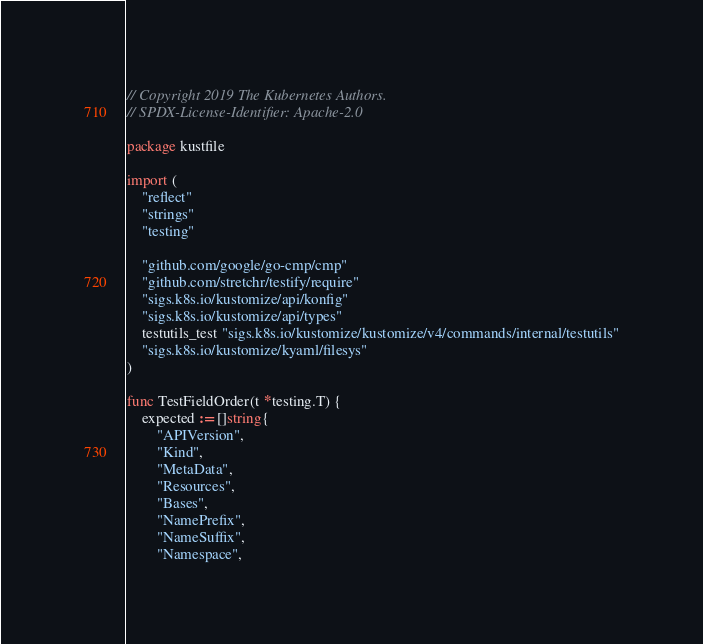Convert code to text. <code><loc_0><loc_0><loc_500><loc_500><_Go_>// Copyright 2019 The Kubernetes Authors.
// SPDX-License-Identifier: Apache-2.0

package kustfile

import (
	"reflect"
	"strings"
	"testing"

	"github.com/google/go-cmp/cmp"
	"github.com/stretchr/testify/require"
	"sigs.k8s.io/kustomize/api/konfig"
	"sigs.k8s.io/kustomize/api/types"
	testutils_test "sigs.k8s.io/kustomize/kustomize/v4/commands/internal/testutils"
	"sigs.k8s.io/kustomize/kyaml/filesys"
)

func TestFieldOrder(t *testing.T) {
	expected := []string{
		"APIVersion",
		"Kind",
		"MetaData",
		"Resources",
		"Bases",
		"NamePrefix",
		"NameSuffix",
		"Namespace",</code> 